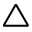Convert formula to latex. <formula><loc_0><loc_0><loc_500><loc_500>\bigtriangleup</formula> 